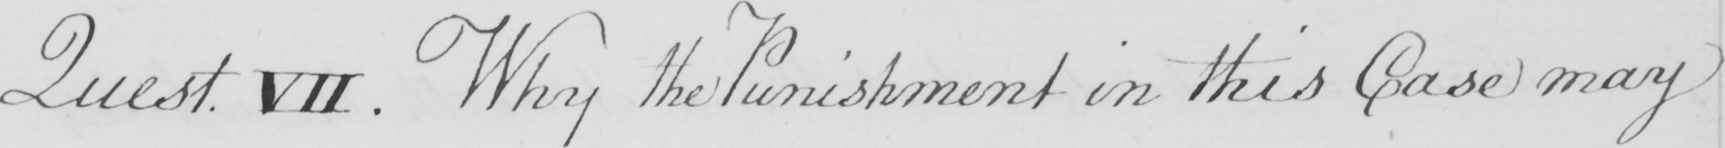Please transcribe the handwritten text in this image. Quest VII . Why the Punishment in this Case may 